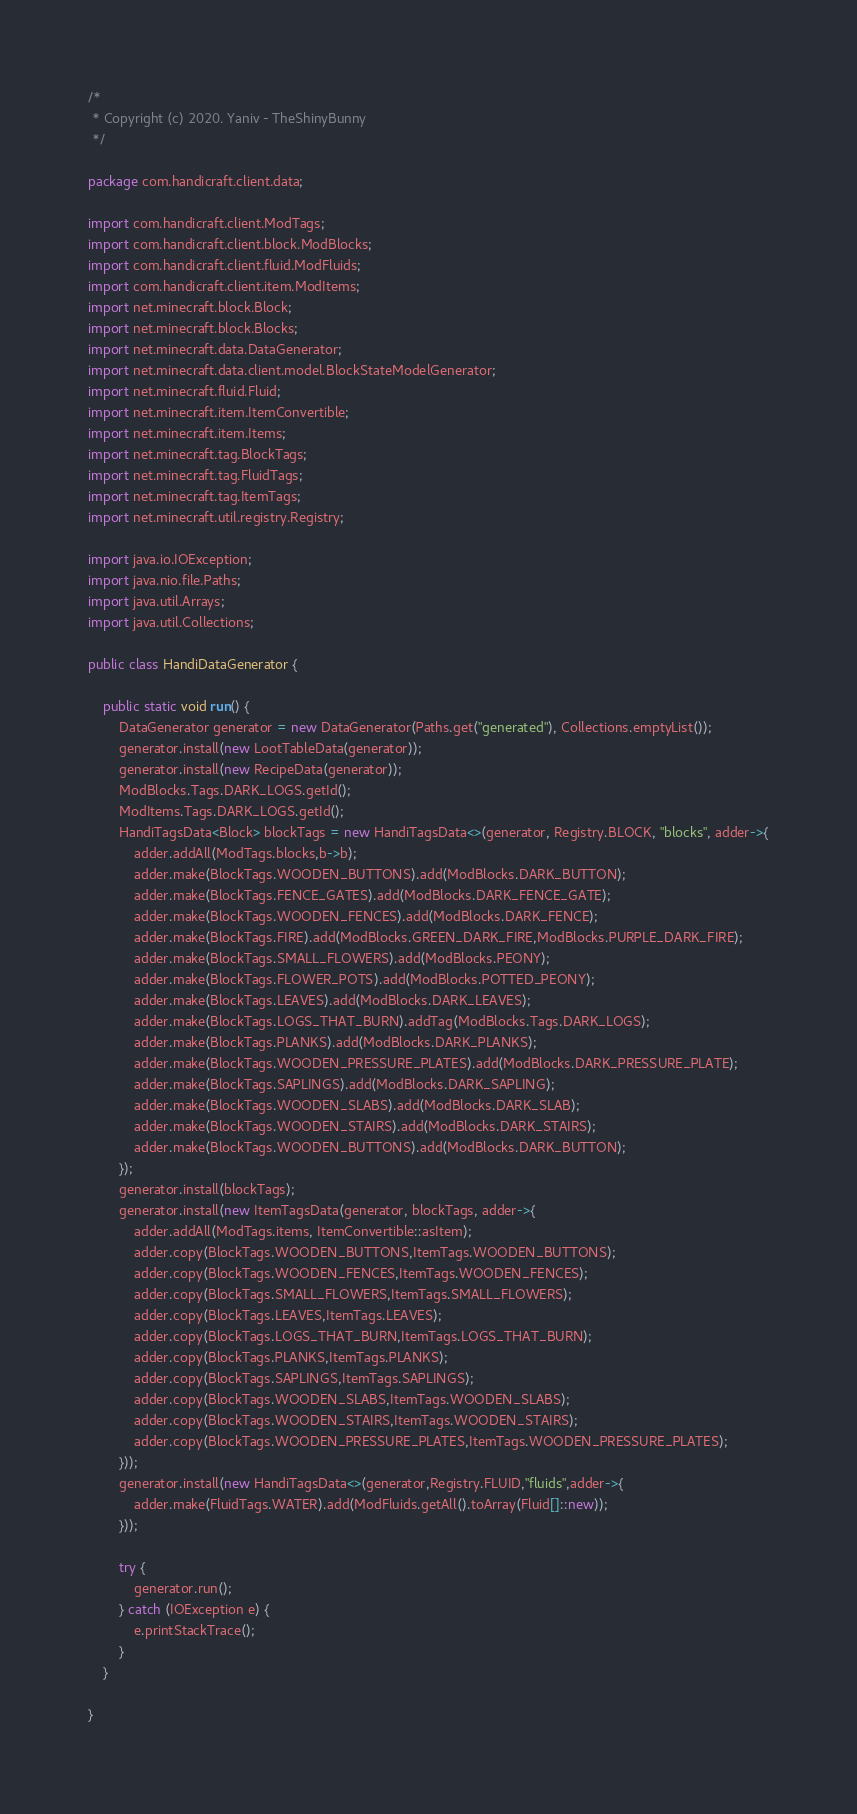Convert code to text. <code><loc_0><loc_0><loc_500><loc_500><_Java_>/*
 * Copyright (c) 2020. Yaniv - TheShinyBunny
 */

package com.handicraft.client.data;

import com.handicraft.client.ModTags;
import com.handicraft.client.block.ModBlocks;
import com.handicraft.client.fluid.ModFluids;
import com.handicraft.client.item.ModItems;
import net.minecraft.block.Block;
import net.minecraft.block.Blocks;
import net.minecraft.data.DataGenerator;
import net.minecraft.data.client.model.BlockStateModelGenerator;
import net.minecraft.fluid.Fluid;
import net.minecraft.item.ItemConvertible;
import net.minecraft.item.Items;
import net.minecraft.tag.BlockTags;
import net.minecraft.tag.FluidTags;
import net.minecraft.tag.ItemTags;
import net.minecraft.util.registry.Registry;

import java.io.IOException;
import java.nio.file.Paths;
import java.util.Arrays;
import java.util.Collections;

public class HandiDataGenerator {

    public static void run() {
        DataGenerator generator = new DataGenerator(Paths.get("generated"), Collections.emptyList());
        generator.install(new LootTableData(generator));
        generator.install(new RecipeData(generator));
        ModBlocks.Tags.DARK_LOGS.getId();
        ModItems.Tags.DARK_LOGS.getId();
        HandiTagsData<Block> blockTags = new HandiTagsData<>(generator, Registry.BLOCK, "blocks", adder->{
            adder.addAll(ModTags.blocks,b->b);
            adder.make(BlockTags.WOODEN_BUTTONS).add(ModBlocks.DARK_BUTTON);
            adder.make(BlockTags.FENCE_GATES).add(ModBlocks.DARK_FENCE_GATE);
            adder.make(BlockTags.WOODEN_FENCES).add(ModBlocks.DARK_FENCE);
            adder.make(BlockTags.FIRE).add(ModBlocks.GREEN_DARK_FIRE,ModBlocks.PURPLE_DARK_FIRE);
            adder.make(BlockTags.SMALL_FLOWERS).add(ModBlocks.PEONY);
            adder.make(BlockTags.FLOWER_POTS).add(ModBlocks.POTTED_PEONY);
            adder.make(BlockTags.LEAVES).add(ModBlocks.DARK_LEAVES);
            adder.make(BlockTags.LOGS_THAT_BURN).addTag(ModBlocks.Tags.DARK_LOGS);
            adder.make(BlockTags.PLANKS).add(ModBlocks.DARK_PLANKS);
            adder.make(BlockTags.WOODEN_PRESSURE_PLATES).add(ModBlocks.DARK_PRESSURE_PLATE);
            adder.make(BlockTags.SAPLINGS).add(ModBlocks.DARK_SAPLING);
            adder.make(BlockTags.WOODEN_SLABS).add(ModBlocks.DARK_SLAB);
            adder.make(BlockTags.WOODEN_STAIRS).add(ModBlocks.DARK_STAIRS);
            adder.make(BlockTags.WOODEN_BUTTONS).add(ModBlocks.DARK_BUTTON);
        });
        generator.install(blockTags);
        generator.install(new ItemTagsData(generator, blockTags, adder->{
            adder.addAll(ModTags.items, ItemConvertible::asItem);
            adder.copy(BlockTags.WOODEN_BUTTONS,ItemTags.WOODEN_BUTTONS);
            adder.copy(BlockTags.WOODEN_FENCES,ItemTags.WOODEN_FENCES);
            adder.copy(BlockTags.SMALL_FLOWERS,ItemTags.SMALL_FLOWERS);
            adder.copy(BlockTags.LEAVES,ItemTags.LEAVES);
            adder.copy(BlockTags.LOGS_THAT_BURN,ItemTags.LOGS_THAT_BURN);
            adder.copy(BlockTags.PLANKS,ItemTags.PLANKS);
            adder.copy(BlockTags.SAPLINGS,ItemTags.SAPLINGS);
            adder.copy(BlockTags.WOODEN_SLABS,ItemTags.WOODEN_SLABS);
            adder.copy(BlockTags.WOODEN_STAIRS,ItemTags.WOODEN_STAIRS);
            adder.copy(BlockTags.WOODEN_PRESSURE_PLATES,ItemTags.WOODEN_PRESSURE_PLATES);
        }));
        generator.install(new HandiTagsData<>(generator,Registry.FLUID,"fluids",adder->{
            adder.make(FluidTags.WATER).add(ModFluids.getAll().toArray(Fluid[]::new));
        }));

        try {
            generator.run();
        } catch (IOException e) {
            e.printStackTrace();
        }
    }

}
</code> 